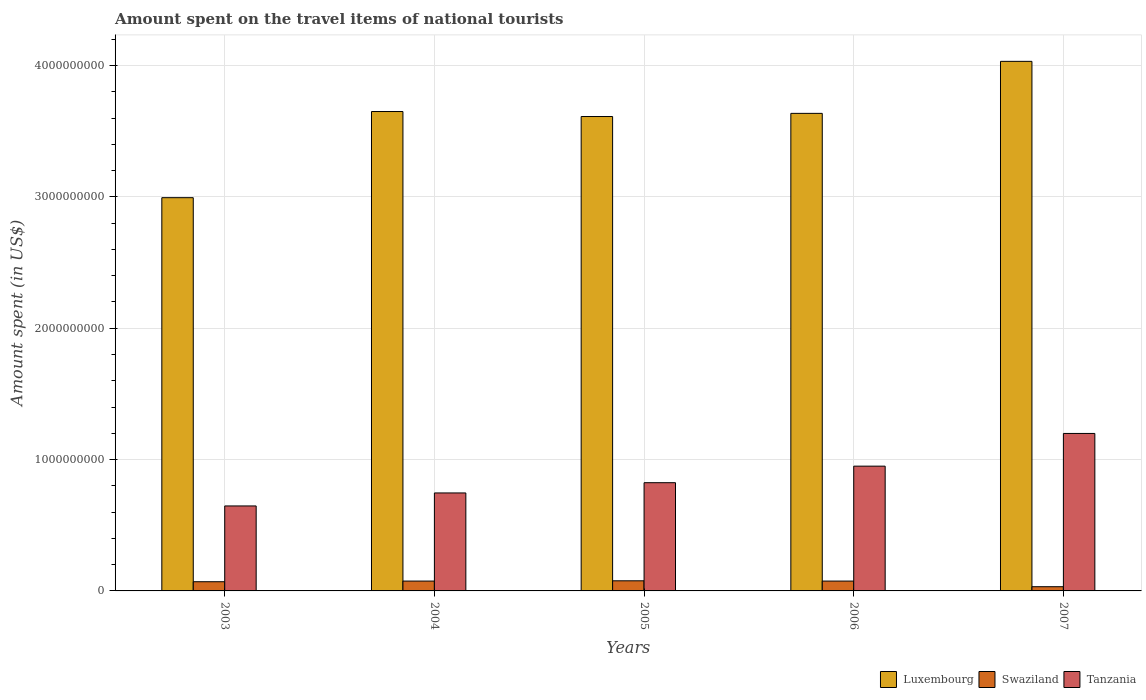How many different coloured bars are there?
Your answer should be very brief. 3. How many groups of bars are there?
Offer a very short reply. 5. Are the number of bars per tick equal to the number of legend labels?
Offer a terse response. Yes. Are the number of bars on each tick of the X-axis equal?
Offer a very short reply. Yes. What is the label of the 3rd group of bars from the left?
Provide a succinct answer. 2005. What is the amount spent on the travel items of national tourists in Swaziland in 2005?
Give a very brief answer. 7.70e+07. Across all years, what is the maximum amount spent on the travel items of national tourists in Swaziland?
Ensure brevity in your answer.  7.70e+07. Across all years, what is the minimum amount spent on the travel items of national tourists in Luxembourg?
Keep it short and to the point. 2.99e+09. In which year was the amount spent on the travel items of national tourists in Luxembourg minimum?
Keep it short and to the point. 2003. What is the total amount spent on the travel items of national tourists in Swaziland in the graph?
Offer a terse response. 3.29e+08. What is the difference between the amount spent on the travel items of national tourists in Swaziland in 2003 and that in 2006?
Ensure brevity in your answer.  -5.00e+06. What is the difference between the amount spent on the travel items of national tourists in Swaziland in 2003 and the amount spent on the travel items of national tourists in Luxembourg in 2006?
Offer a terse response. -3.57e+09. What is the average amount spent on the travel items of national tourists in Swaziland per year?
Offer a very short reply. 6.58e+07. In the year 2003, what is the difference between the amount spent on the travel items of national tourists in Luxembourg and amount spent on the travel items of national tourists in Swaziland?
Make the answer very short. 2.92e+09. What is the ratio of the amount spent on the travel items of national tourists in Luxembourg in 2003 to that in 2007?
Your response must be concise. 0.74. Is the amount spent on the travel items of national tourists in Tanzania in 2003 less than that in 2006?
Offer a very short reply. Yes. Is the difference between the amount spent on the travel items of national tourists in Luxembourg in 2004 and 2006 greater than the difference between the amount spent on the travel items of national tourists in Swaziland in 2004 and 2006?
Offer a very short reply. Yes. What is the difference between the highest and the second highest amount spent on the travel items of national tourists in Tanzania?
Your response must be concise. 2.49e+08. What is the difference between the highest and the lowest amount spent on the travel items of national tourists in Luxembourg?
Your answer should be very brief. 1.04e+09. In how many years, is the amount spent on the travel items of national tourists in Luxembourg greater than the average amount spent on the travel items of national tourists in Luxembourg taken over all years?
Give a very brief answer. 4. What does the 3rd bar from the left in 2005 represents?
Offer a terse response. Tanzania. What does the 3rd bar from the right in 2004 represents?
Your answer should be very brief. Luxembourg. How many bars are there?
Ensure brevity in your answer.  15. Are all the bars in the graph horizontal?
Offer a terse response. No. What is the difference between two consecutive major ticks on the Y-axis?
Your answer should be compact. 1.00e+09. Are the values on the major ticks of Y-axis written in scientific E-notation?
Give a very brief answer. No. Does the graph contain grids?
Your answer should be compact. Yes. Where does the legend appear in the graph?
Provide a succinct answer. Bottom right. What is the title of the graph?
Make the answer very short. Amount spent on the travel items of national tourists. What is the label or title of the Y-axis?
Offer a very short reply. Amount spent (in US$). What is the Amount spent (in US$) of Luxembourg in 2003?
Offer a terse response. 2.99e+09. What is the Amount spent (in US$) of Swaziland in 2003?
Make the answer very short. 7.00e+07. What is the Amount spent (in US$) in Tanzania in 2003?
Provide a succinct answer. 6.47e+08. What is the Amount spent (in US$) in Luxembourg in 2004?
Your response must be concise. 3.65e+09. What is the Amount spent (in US$) in Swaziland in 2004?
Your response must be concise. 7.50e+07. What is the Amount spent (in US$) of Tanzania in 2004?
Make the answer very short. 7.46e+08. What is the Amount spent (in US$) in Luxembourg in 2005?
Provide a short and direct response. 3.61e+09. What is the Amount spent (in US$) of Swaziland in 2005?
Your response must be concise. 7.70e+07. What is the Amount spent (in US$) of Tanzania in 2005?
Your answer should be very brief. 8.24e+08. What is the Amount spent (in US$) in Luxembourg in 2006?
Give a very brief answer. 3.64e+09. What is the Amount spent (in US$) in Swaziland in 2006?
Your answer should be very brief. 7.50e+07. What is the Amount spent (in US$) of Tanzania in 2006?
Keep it short and to the point. 9.50e+08. What is the Amount spent (in US$) in Luxembourg in 2007?
Keep it short and to the point. 4.03e+09. What is the Amount spent (in US$) of Swaziland in 2007?
Make the answer very short. 3.20e+07. What is the Amount spent (in US$) of Tanzania in 2007?
Your answer should be very brief. 1.20e+09. Across all years, what is the maximum Amount spent (in US$) in Luxembourg?
Give a very brief answer. 4.03e+09. Across all years, what is the maximum Amount spent (in US$) of Swaziland?
Your answer should be compact. 7.70e+07. Across all years, what is the maximum Amount spent (in US$) in Tanzania?
Your answer should be compact. 1.20e+09. Across all years, what is the minimum Amount spent (in US$) in Luxembourg?
Make the answer very short. 2.99e+09. Across all years, what is the minimum Amount spent (in US$) of Swaziland?
Make the answer very short. 3.20e+07. Across all years, what is the minimum Amount spent (in US$) of Tanzania?
Give a very brief answer. 6.47e+08. What is the total Amount spent (in US$) of Luxembourg in the graph?
Make the answer very short. 1.79e+1. What is the total Amount spent (in US$) in Swaziland in the graph?
Make the answer very short. 3.29e+08. What is the total Amount spent (in US$) in Tanzania in the graph?
Offer a very short reply. 4.37e+09. What is the difference between the Amount spent (in US$) in Luxembourg in 2003 and that in 2004?
Your answer should be very brief. -6.56e+08. What is the difference between the Amount spent (in US$) in Swaziland in 2003 and that in 2004?
Offer a terse response. -5.00e+06. What is the difference between the Amount spent (in US$) of Tanzania in 2003 and that in 2004?
Make the answer very short. -9.90e+07. What is the difference between the Amount spent (in US$) in Luxembourg in 2003 and that in 2005?
Give a very brief answer. -6.18e+08. What is the difference between the Amount spent (in US$) in Swaziland in 2003 and that in 2005?
Give a very brief answer. -7.00e+06. What is the difference between the Amount spent (in US$) of Tanzania in 2003 and that in 2005?
Keep it short and to the point. -1.77e+08. What is the difference between the Amount spent (in US$) in Luxembourg in 2003 and that in 2006?
Provide a succinct answer. -6.42e+08. What is the difference between the Amount spent (in US$) of Swaziland in 2003 and that in 2006?
Your answer should be compact. -5.00e+06. What is the difference between the Amount spent (in US$) of Tanzania in 2003 and that in 2006?
Your response must be concise. -3.03e+08. What is the difference between the Amount spent (in US$) of Luxembourg in 2003 and that in 2007?
Ensure brevity in your answer.  -1.04e+09. What is the difference between the Amount spent (in US$) in Swaziland in 2003 and that in 2007?
Ensure brevity in your answer.  3.80e+07. What is the difference between the Amount spent (in US$) of Tanzania in 2003 and that in 2007?
Your response must be concise. -5.52e+08. What is the difference between the Amount spent (in US$) of Luxembourg in 2004 and that in 2005?
Keep it short and to the point. 3.80e+07. What is the difference between the Amount spent (in US$) of Swaziland in 2004 and that in 2005?
Ensure brevity in your answer.  -2.00e+06. What is the difference between the Amount spent (in US$) in Tanzania in 2004 and that in 2005?
Your answer should be very brief. -7.80e+07. What is the difference between the Amount spent (in US$) of Luxembourg in 2004 and that in 2006?
Keep it short and to the point. 1.40e+07. What is the difference between the Amount spent (in US$) in Tanzania in 2004 and that in 2006?
Your response must be concise. -2.04e+08. What is the difference between the Amount spent (in US$) of Luxembourg in 2004 and that in 2007?
Keep it short and to the point. -3.82e+08. What is the difference between the Amount spent (in US$) of Swaziland in 2004 and that in 2007?
Give a very brief answer. 4.30e+07. What is the difference between the Amount spent (in US$) of Tanzania in 2004 and that in 2007?
Provide a short and direct response. -4.53e+08. What is the difference between the Amount spent (in US$) of Luxembourg in 2005 and that in 2006?
Your answer should be very brief. -2.40e+07. What is the difference between the Amount spent (in US$) of Swaziland in 2005 and that in 2006?
Offer a terse response. 2.00e+06. What is the difference between the Amount spent (in US$) of Tanzania in 2005 and that in 2006?
Give a very brief answer. -1.26e+08. What is the difference between the Amount spent (in US$) in Luxembourg in 2005 and that in 2007?
Provide a short and direct response. -4.20e+08. What is the difference between the Amount spent (in US$) of Swaziland in 2005 and that in 2007?
Your answer should be very brief. 4.50e+07. What is the difference between the Amount spent (in US$) in Tanzania in 2005 and that in 2007?
Your answer should be very brief. -3.75e+08. What is the difference between the Amount spent (in US$) of Luxembourg in 2006 and that in 2007?
Offer a very short reply. -3.96e+08. What is the difference between the Amount spent (in US$) of Swaziland in 2006 and that in 2007?
Ensure brevity in your answer.  4.30e+07. What is the difference between the Amount spent (in US$) of Tanzania in 2006 and that in 2007?
Offer a terse response. -2.49e+08. What is the difference between the Amount spent (in US$) in Luxembourg in 2003 and the Amount spent (in US$) in Swaziland in 2004?
Keep it short and to the point. 2.92e+09. What is the difference between the Amount spent (in US$) of Luxembourg in 2003 and the Amount spent (in US$) of Tanzania in 2004?
Make the answer very short. 2.25e+09. What is the difference between the Amount spent (in US$) of Swaziland in 2003 and the Amount spent (in US$) of Tanzania in 2004?
Your answer should be compact. -6.76e+08. What is the difference between the Amount spent (in US$) of Luxembourg in 2003 and the Amount spent (in US$) of Swaziland in 2005?
Give a very brief answer. 2.92e+09. What is the difference between the Amount spent (in US$) in Luxembourg in 2003 and the Amount spent (in US$) in Tanzania in 2005?
Keep it short and to the point. 2.17e+09. What is the difference between the Amount spent (in US$) of Swaziland in 2003 and the Amount spent (in US$) of Tanzania in 2005?
Provide a succinct answer. -7.54e+08. What is the difference between the Amount spent (in US$) in Luxembourg in 2003 and the Amount spent (in US$) in Swaziland in 2006?
Make the answer very short. 2.92e+09. What is the difference between the Amount spent (in US$) in Luxembourg in 2003 and the Amount spent (in US$) in Tanzania in 2006?
Your response must be concise. 2.04e+09. What is the difference between the Amount spent (in US$) in Swaziland in 2003 and the Amount spent (in US$) in Tanzania in 2006?
Provide a succinct answer. -8.80e+08. What is the difference between the Amount spent (in US$) in Luxembourg in 2003 and the Amount spent (in US$) in Swaziland in 2007?
Your answer should be compact. 2.96e+09. What is the difference between the Amount spent (in US$) in Luxembourg in 2003 and the Amount spent (in US$) in Tanzania in 2007?
Give a very brief answer. 1.80e+09. What is the difference between the Amount spent (in US$) of Swaziland in 2003 and the Amount spent (in US$) of Tanzania in 2007?
Your answer should be compact. -1.13e+09. What is the difference between the Amount spent (in US$) in Luxembourg in 2004 and the Amount spent (in US$) in Swaziland in 2005?
Your response must be concise. 3.57e+09. What is the difference between the Amount spent (in US$) of Luxembourg in 2004 and the Amount spent (in US$) of Tanzania in 2005?
Provide a succinct answer. 2.83e+09. What is the difference between the Amount spent (in US$) of Swaziland in 2004 and the Amount spent (in US$) of Tanzania in 2005?
Provide a short and direct response. -7.49e+08. What is the difference between the Amount spent (in US$) in Luxembourg in 2004 and the Amount spent (in US$) in Swaziland in 2006?
Make the answer very short. 3.58e+09. What is the difference between the Amount spent (in US$) of Luxembourg in 2004 and the Amount spent (in US$) of Tanzania in 2006?
Provide a short and direct response. 2.70e+09. What is the difference between the Amount spent (in US$) in Swaziland in 2004 and the Amount spent (in US$) in Tanzania in 2006?
Your response must be concise. -8.75e+08. What is the difference between the Amount spent (in US$) of Luxembourg in 2004 and the Amount spent (in US$) of Swaziland in 2007?
Make the answer very short. 3.62e+09. What is the difference between the Amount spent (in US$) in Luxembourg in 2004 and the Amount spent (in US$) in Tanzania in 2007?
Offer a very short reply. 2.45e+09. What is the difference between the Amount spent (in US$) of Swaziland in 2004 and the Amount spent (in US$) of Tanzania in 2007?
Make the answer very short. -1.12e+09. What is the difference between the Amount spent (in US$) in Luxembourg in 2005 and the Amount spent (in US$) in Swaziland in 2006?
Your answer should be very brief. 3.54e+09. What is the difference between the Amount spent (in US$) of Luxembourg in 2005 and the Amount spent (in US$) of Tanzania in 2006?
Provide a short and direct response. 2.66e+09. What is the difference between the Amount spent (in US$) of Swaziland in 2005 and the Amount spent (in US$) of Tanzania in 2006?
Your response must be concise. -8.73e+08. What is the difference between the Amount spent (in US$) in Luxembourg in 2005 and the Amount spent (in US$) in Swaziland in 2007?
Your answer should be compact. 3.58e+09. What is the difference between the Amount spent (in US$) of Luxembourg in 2005 and the Amount spent (in US$) of Tanzania in 2007?
Your answer should be compact. 2.41e+09. What is the difference between the Amount spent (in US$) of Swaziland in 2005 and the Amount spent (in US$) of Tanzania in 2007?
Provide a succinct answer. -1.12e+09. What is the difference between the Amount spent (in US$) of Luxembourg in 2006 and the Amount spent (in US$) of Swaziland in 2007?
Provide a short and direct response. 3.60e+09. What is the difference between the Amount spent (in US$) in Luxembourg in 2006 and the Amount spent (in US$) in Tanzania in 2007?
Provide a succinct answer. 2.44e+09. What is the difference between the Amount spent (in US$) in Swaziland in 2006 and the Amount spent (in US$) in Tanzania in 2007?
Your answer should be compact. -1.12e+09. What is the average Amount spent (in US$) of Luxembourg per year?
Offer a terse response. 3.58e+09. What is the average Amount spent (in US$) in Swaziland per year?
Ensure brevity in your answer.  6.58e+07. What is the average Amount spent (in US$) in Tanzania per year?
Provide a short and direct response. 8.73e+08. In the year 2003, what is the difference between the Amount spent (in US$) of Luxembourg and Amount spent (in US$) of Swaziland?
Give a very brief answer. 2.92e+09. In the year 2003, what is the difference between the Amount spent (in US$) in Luxembourg and Amount spent (in US$) in Tanzania?
Offer a terse response. 2.35e+09. In the year 2003, what is the difference between the Amount spent (in US$) in Swaziland and Amount spent (in US$) in Tanzania?
Offer a very short reply. -5.77e+08. In the year 2004, what is the difference between the Amount spent (in US$) of Luxembourg and Amount spent (in US$) of Swaziland?
Give a very brief answer. 3.58e+09. In the year 2004, what is the difference between the Amount spent (in US$) in Luxembourg and Amount spent (in US$) in Tanzania?
Your answer should be very brief. 2.90e+09. In the year 2004, what is the difference between the Amount spent (in US$) of Swaziland and Amount spent (in US$) of Tanzania?
Make the answer very short. -6.71e+08. In the year 2005, what is the difference between the Amount spent (in US$) of Luxembourg and Amount spent (in US$) of Swaziland?
Make the answer very short. 3.54e+09. In the year 2005, what is the difference between the Amount spent (in US$) in Luxembourg and Amount spent (in US$) in Tanzania?
Your response must be concise. 2.79e+09. In the year 2005, what is the difference between the Amount spent (in US$) of Swaziland and Amount spent (in US$) of Tanzania?
Your answer should be compact. -7.47e+08. In the year 2006, what is the difference between the Amount spent (in US$) of Luxembourg and Amount spent (in US$) of Swaziland?
Provide a succinct answer. 3.56e+09. In the year 2006, what is the difference between the Amount spent (in US$) in Luxembourg and Amount spent (in US$) in Tanzania?
Provide a succinct answer. 2.69e+09. In the year 2006, what is the difference between the Amount spent (in US$) of Swaziland and Amount spent (in US$) of Tanzania?
Provide a succinct answer. -8.75e+08. In the year 2007, what is the difference between the Amount spent (in US$) of Luxembourg and Amount spent (in US$) of Swaziland?
Your answer should be very brief. 4.00e+09. In the year 2007, what is the difference between the Amount spent (in US$) in Luxembourg and Amount spent (in US$) in Tanzania?
Make the answer very short. 2.83e+09. In the year 2007, what is the difference between the Amount spent (in US$) in Swaziland and Amount spent (in US$) in Tanzania?
Offer a terse response. -1.17e+09. What is the ratio of the Amount spent (in US$) in Luxembourg in 2003 to that in 2004?
Offer a very short reply. 0.82. What is the ratio of the Amount spent (in US$) of Swaziland in 2003 to that in 2004?
Make the answer very short. 0.93. What is the ratio of the Amount spent (in US$) in Tanzania in 2003 to that in 2004?
Your answer should be very brief. 0.87. What is the ratio of the Amount spent (in US$) of Luxembourg in 2003 to that in 2005?
Keep it short and to the point. 0.83. What is the ratio of the Amount spent (in US$) of Tanzania in 2003 to that in 2005?
Provide a short and direct response. 0.79. What is the ratio of the Amount spent (in US$) of Luxembourg in 2003 to that in 2006?
Provide a short and direct response. 0.82. What is the ratio of the Amount spent (in US$) in Swaziland in 2003 to that in 2006?
Provide a succinct answer. 0.93. What is the ratio of the Amount spent (in US$) in Tanzania in 2003 to that in 2006?
Your answer should be compact. 0.68. What is the ratio of the Amount spent (in US$) of Luxembourg in 2003 to that in 2007?
Ensure brevity in your answer.  0.74. What is the ratio of the Amount spent (in US$) in Swaziland in 2003 to that in 2007?
Offer a very short reply. 2.19. What is the ratio of the Amount spent (in US$) in Tanzania in 2003 to that in 2007?
Your response must be concise. 0.54. What is the ratio of the Amount spent (in US$) of Luxembourg in 2004 to that in 2005?
Your answer should be very brief. 1.01. What is the ratio of the Amount spent (in US$) of Tanzania in 2004 to that in 2005?
Offer a terse response. 0.91. What is the ratio of the Amount spent (in US$) of Luxembourg in 2004 to that in 2006?
Your response must be concise. 1. What is the ratio of the Amount spent (in US$) in Swaziland in 2004 to that in 2006?
Your answer should be compact. 1. What is the ratio of the Amount spent (in US$) of Tanzania in 2004 to that in 2006?
Give a very brief answer. 0.79. What is the ratio of the Amount spent (in US$) in Luxembourg in 2004 to that in 2007?
Provide a short and direct response. 0.91. What is the ratio of the Amount spent (in US$) of Swaziland in 2004 to that in 2007?
Provide a succinct answer. 2.34. What is the ratio of the Amount spent (in US$) in Tanzania in 2004 to that in 2007?
Give a very brief answer. 0.62. What is the ratio of the Amount spent (in US$) of Luxembourg in 2005 to that in 2006?
Your answer should be compact. 0.99. What is the ratio of the Amount spent (in US$) in Swaziland in 2005 to that in 2006?
Ensure brevity in your answer.  1.03. What is the ratio of the Amount spent (in US$) in Tanzania in 2005 to that in 2006?
Make the answer very short. 0.87. What is the ratio of the Amount spent (in US$) of Luxembourg in 2005 to that in 2007?
Offer a terse response. 0.9. What is the ratio of the Amount spent (in US$) in Swaziland in 2005 to that in 2007?
Offer a very short reply. 2.41. What is the ratio of the Amount spent (in US$) in Tanzania in 2005 to that in 2007?
Provide a succinct answer. 0.69. What is the ratio of the Amount spent (in US$) of Luxembourg in 2006 to that in 2007?
Offer a very short reply. 0.9. What is the ratio of the Amount spent (in US$) in Swaziland in 2006 to that in 2007?
Provide a succinct answer. 2.34. What is the ratio of the Amount spent (in US$) of Tanzania in 2006 to that in 2007?
Ensure brevity in your answer.  0.79. What is the difference between the highest and the second highest Amount spent (in US$) in Luxembourg?
Keep it short and to the point. 3.82e+08. What is the difference between the highest and the second highest Amount spent (in US$) of Swaziland?
Your answer should be compact. 2.00e+06. What is the difference between the highest and the second highest Amount spent (in US$) in Tanzania?
Offer a very short reply. 2.49e+08. What is the difference between the highest and the lowest Amount spent (in US$) in Luxembourg?
Keep it short and to the point. 1.04e+09. What is the difference between the highest and the lowest Amount spent (in US$) of Swaziland?
Your answer should be compact. 4.50e+07. What is the difference between the highest and the lowest Amount spent (in US$) in Tanzania?
Keep it short and to the point. 5.52e+08. 